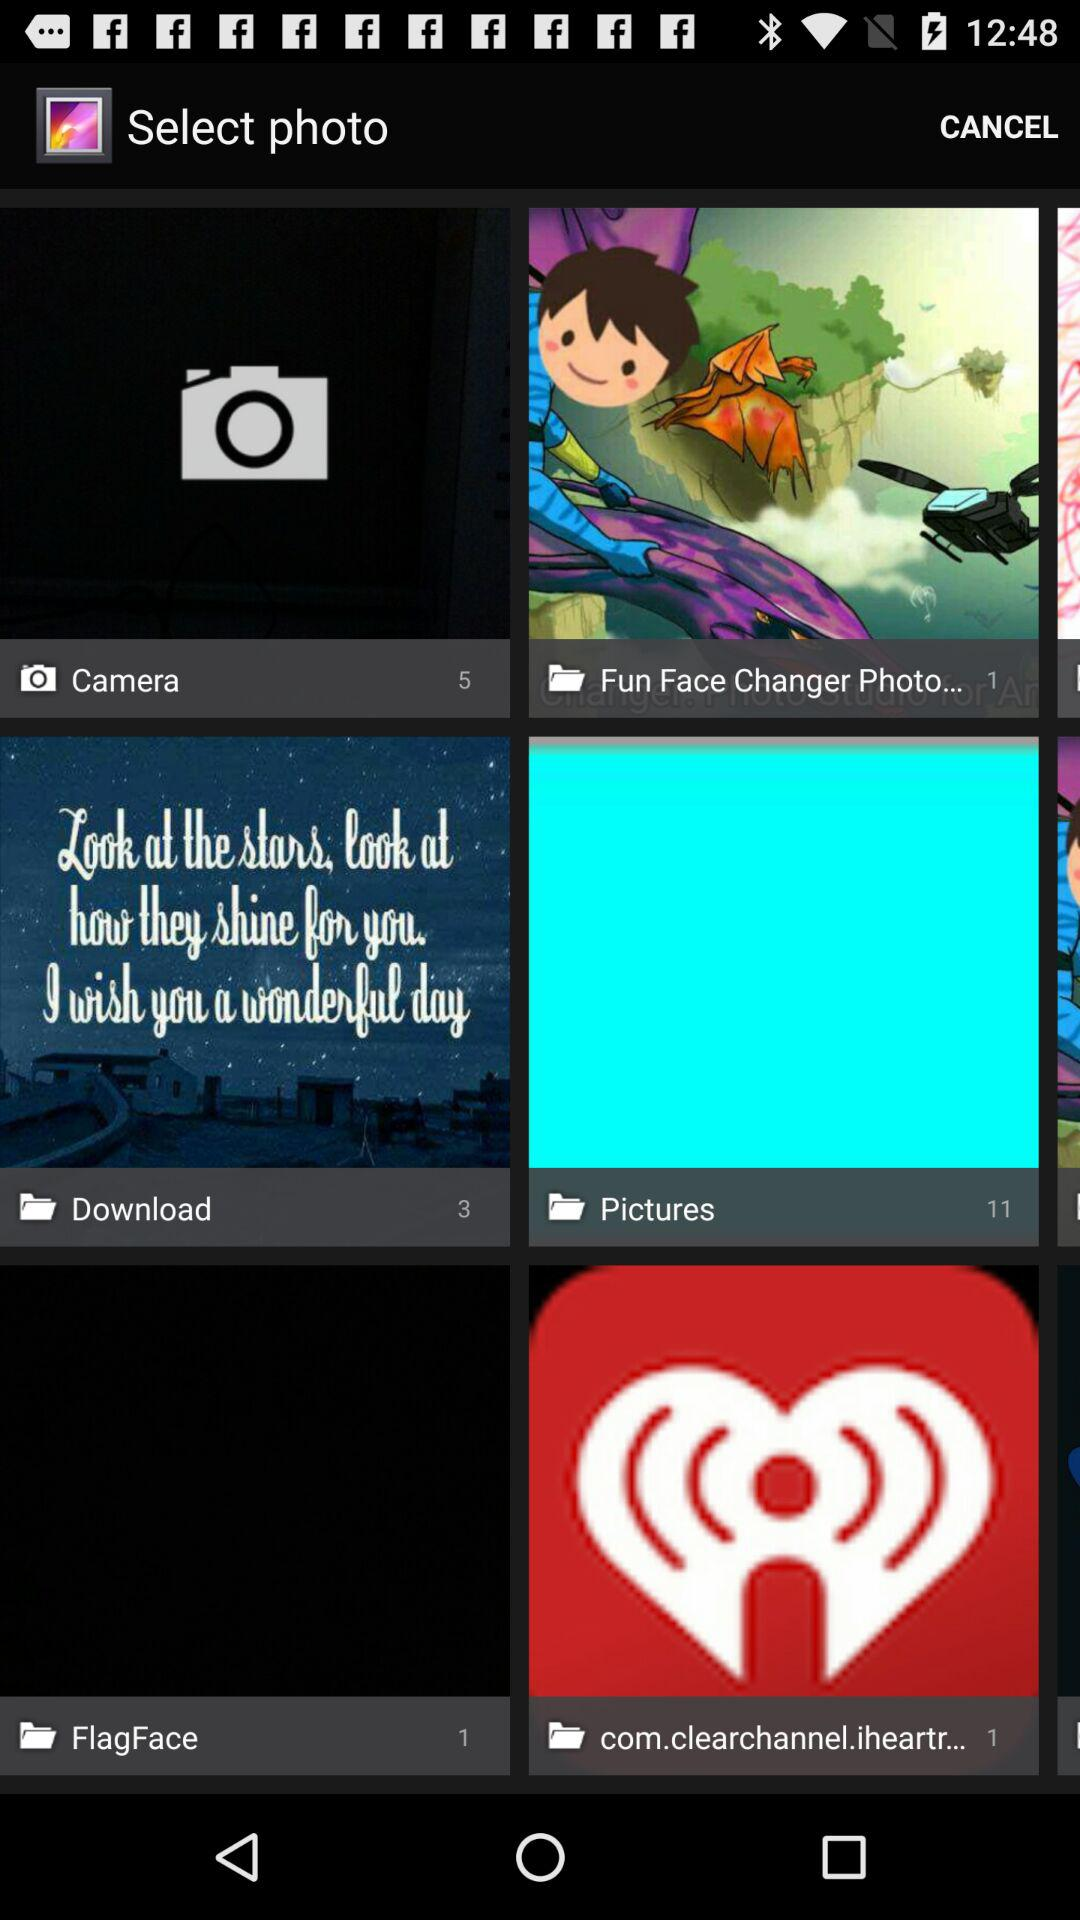How many pictures are in the "Camera" folder? There are 5 pictures in the "Camera" folder. 